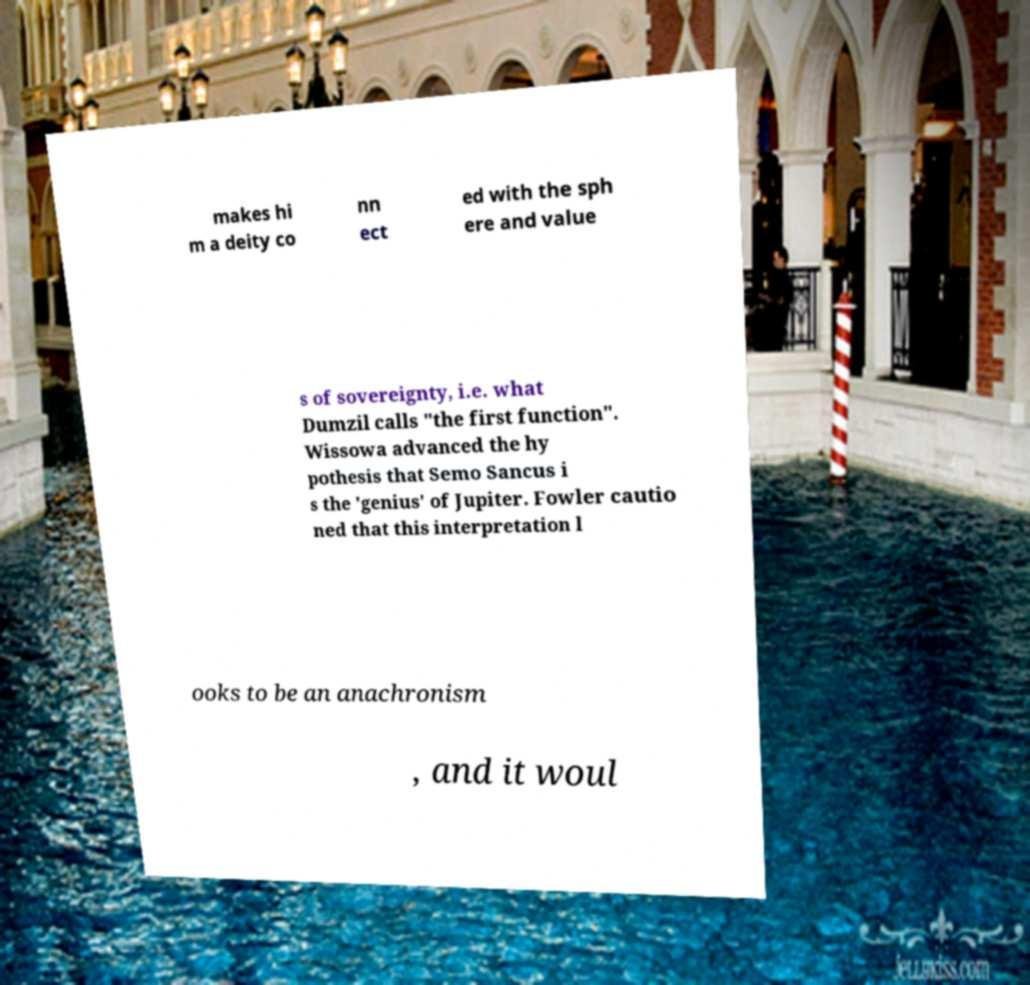What messages or text are displayed in this image? I need them in a readable, typed format. makes hi m a deity co nn ect ed with the sph ere and value s of sovereignty, i.e. what Dumzil calls "the first function". Wissowa advanced the hy pothesis that Semo Sancus i s the 'genius' of Jupiter. Fowler cautio ned that this interpretation l ooks to be an anachronism , and it woul 